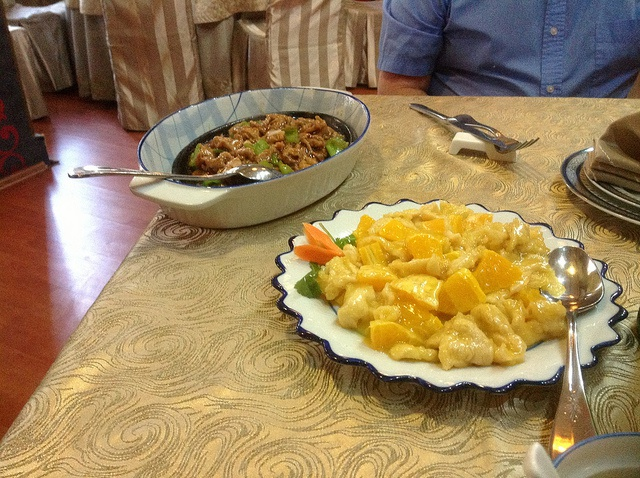Describe the objects in this image and their specific colors. I can see dining table in black, tan, orange, and olive tones, people in black, gray, and navy tones, bowl in black, darkgray, gray, and olive tones, spoon in black, olive, gray, and tan tones, and spoon in black, gray, white, darkgray, and olive tones in this image. 